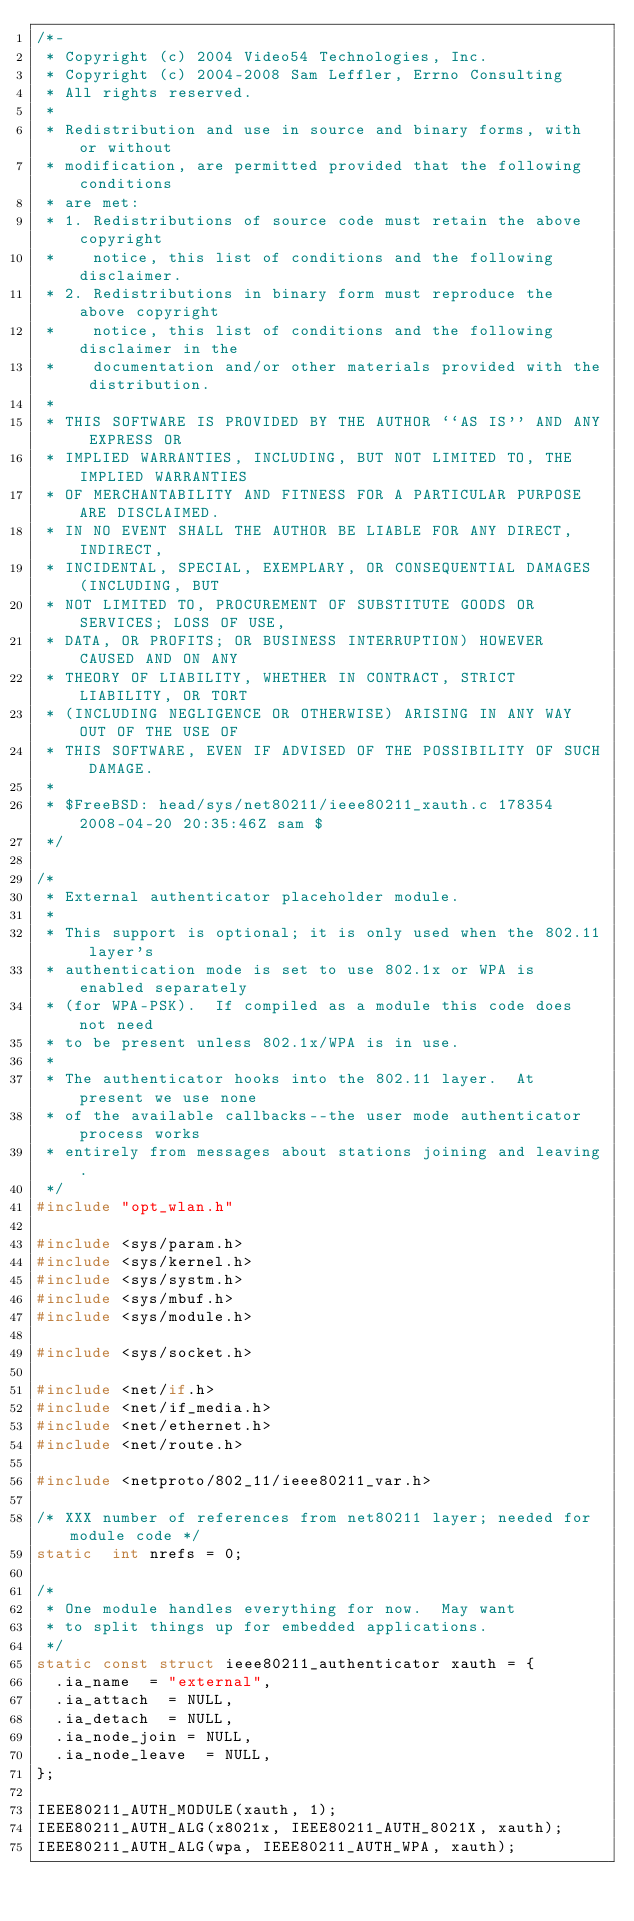<code> <loc_0><loc_0><loc_500><loc_500><_C_>/*-
 * Copyright (c) 2004 Video54 Technologies, Inc.
 * Copyright (c) 2004-2008 Sam Leffler, Errno Consulting
 * All rights reserved.
 *
 * Redistribution and use in source and binary forms, with or without
 * modification, are permitted provided that the following conditions
 * are met:
 * 1. Redistributions of source code must retain the above copyright
 *    notice, this list of conditions and the following disclaimer.
 * 2. Redistributions in binary form must reproduce the above copyright
 *    notice, this list of conditions and the following disclaimer in the
 *    documentation and/or other materials provided with the distribution.
 *
 * THIS SOFTWARE IS PROVIDED BY THE AUTHOR ``AS IS'' AND ANY EXPRESS OR
 * IMPLIED WARRANTIES, INCLUDING, BUT NOT LIMITED TO, THE IMPLIED WARRANTIES
 * OF MERCHANTABILITY AND FITNESS FOR A PARTICULAR PURPOSE ARE DISCLAIMED.
 * IN NO EVENT SHALL THE AUTHOR BE LIABLE FOR ANY DIRECT, INDIRECT,
 * INCIDENTAL, SPECIAL, EXEMPLARY, OR CONSEQUENTIAL DAMAGES (INCLUDING, BUT
 * NOT LIMITED TO, PROCUREMENT OF SUBSTITUTE GOODS OR SERVICES; LOSS OF USE,
 * DATA, OR PROFITS; OR BUSINESS INTERRUPTION) HOWEVER CAUSED AND ON ANY
 * THEORY OF LIABILITY, WHETHER IN CONTRACT, STRICT LIABILITY, OR TORT
 * (INCLUDING NEGLIGENCE OR OTHERWISE) ARISING IN ANY WAY OUT OF THE USE OF
 * THIS SOFTWARE, EVEN IF ADVISED OF THE POSSIBILITY OF SUCH DAMAGE.
 *
 * $FreeBSD: head/sys/net80211/ieee80211_xauth.c 178354 2008-04-20 20:35:46Z sam $
 */

/*
 * External authenticator placeholder module.
 *
 * This support is optional; it is only used when the 802.11 layer's
 * authentication mode is set to use 802.1x or WPA is enabled separately
 * (for WPA-PSK).  If compiled as a module this code does not need
 * to be present unless 802.1x/WPA is in use.
 *
 * The authenticator hooks into the 802.11 layer.  At present we use none
 * of the available callbacks--the user mode authenticator process works
 * entirely from messages about stations joining and leaving.
 */
#include "opt_wlan.h"

#include <sys/param.h>
#include <sys/kernel.h>
#include <sys/systm.h> 
#include <sys/mbuf.h>   
#include <sys/module.h>

#include <sys/socket.h>

#include <net/if.h>
#include <net/if_media.h>
#include <net/ethernet.h>
#include <net/route.h>

#include <netproto/802_11/ieee80211_var.h>

/* XXX number of references from net80211 layer; needed for module code */
static	int nrefs = 0;

/*
 * One module handles everything for now.  May want
 * to split things up for embedded applications.
 */
static const struct ieee80211_authenticator xauth = {
	.ia_name	= "external",
	.ia_attach	= NULL,
	.ia_detach	= NULL,
	.ia_node_join	= NULL,
	.ia_node_leave	= NULL,
};

IEEE80211_AUTH_MODULE(xauth, 1);
IEEE80211_AUTH_ALG(x8021x, IEEE80211_AUTH_8021X, xauth);
IEEE80211_AUTH_ALG(wpa, IEEE80211_AUTH_WPA, xauth);
</code> 